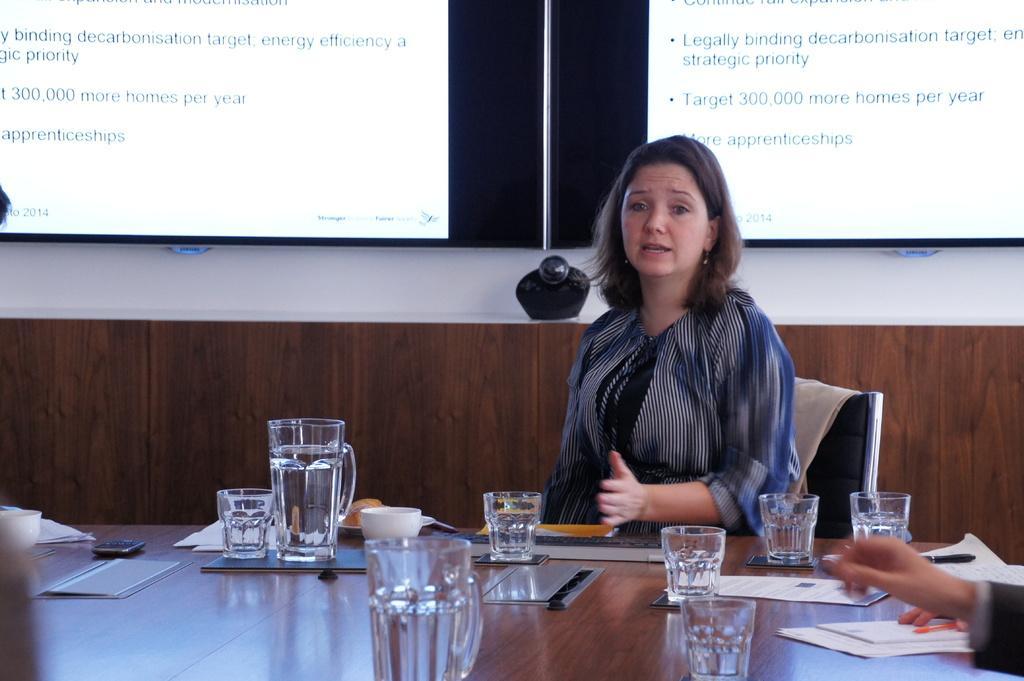In one or two sentences, can you explain what this image depicts? On the background we can see screens. We can see a woman sitting on a chair. talking in front of a table and on the table we can see water glasses, jar, cup, mobile, a dairy , pen and papers. 